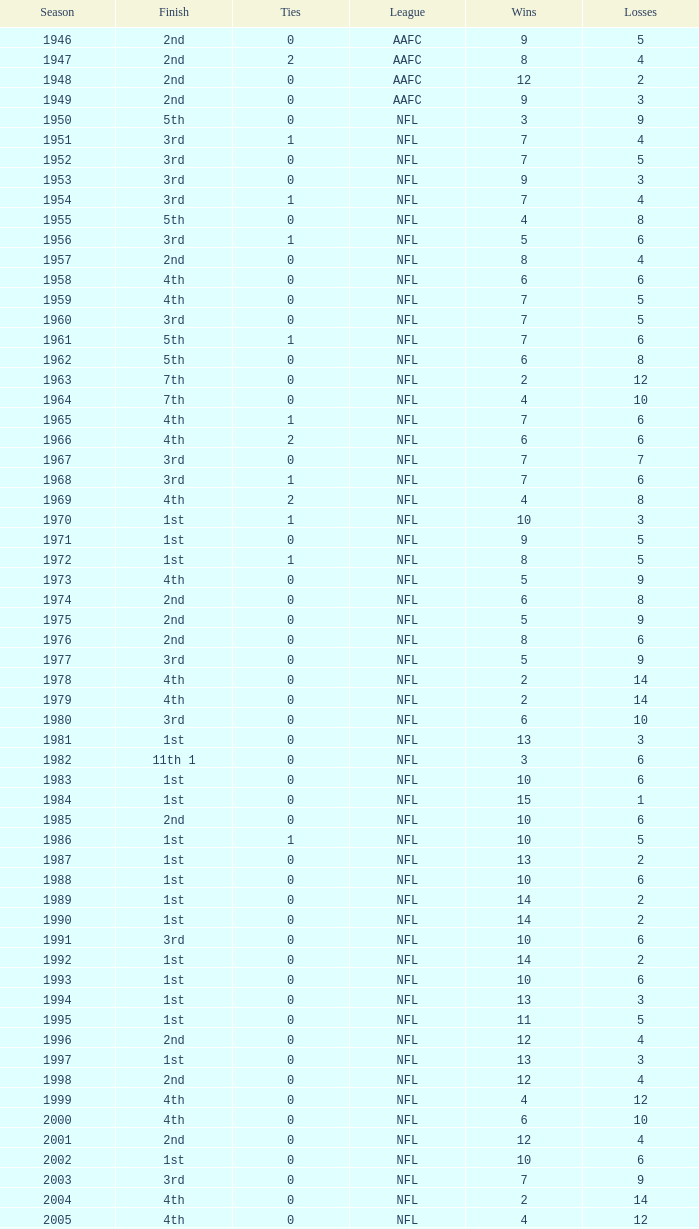What league had a finish of 2nd and 3 losses? AAFC. 